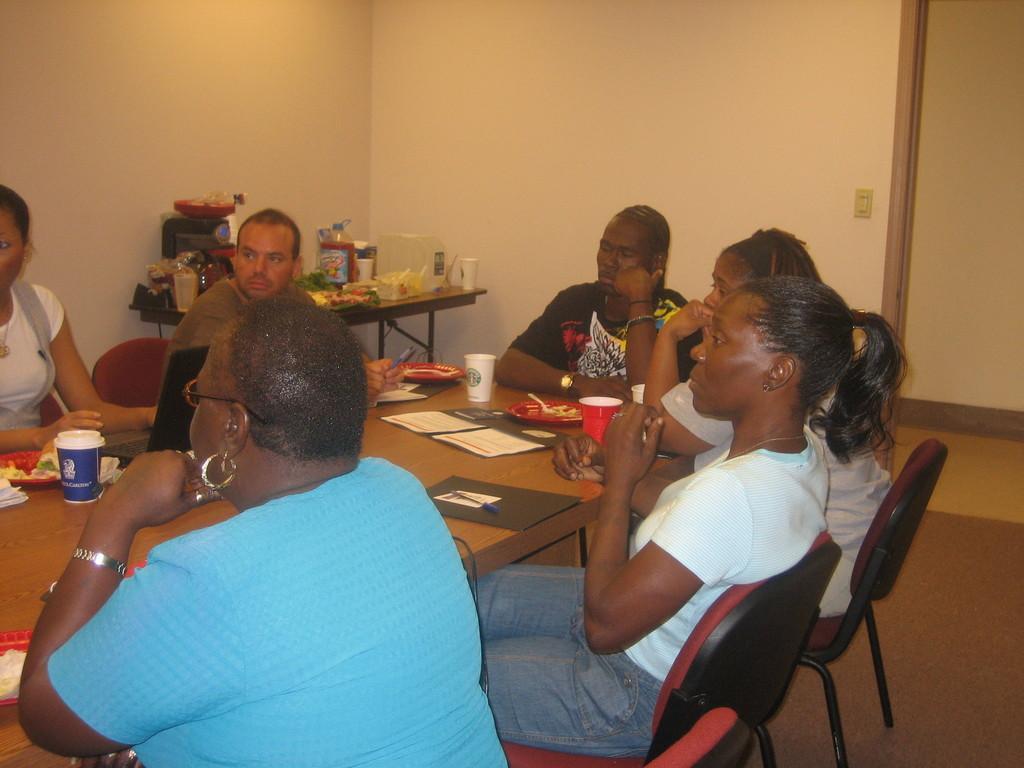In one or two sentences, can you explain what this image depicts? This persons are sitting on a chair. In-front of this person there is a table. On a table there is a paper, cup, plate and spoon. This woman in blue t-shirt wore spectacles and wrist watch. Far there is a table. On a table there are things. 